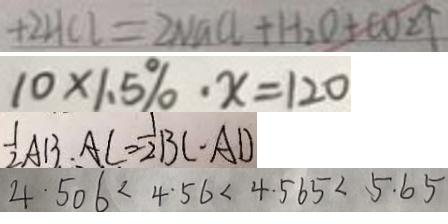<formula> <loc_0><loc_0><loc_500><loc_500>+ 2 H C l = 2 N a C l + H _ { 2 } O + C O _ { 2 } \uparrow 
 1 0 \times 1 . 5 \% \cdot x = 1 2 0 
 \frac { 1 } { 2 } A B \cdot A C = \frac { 1 } { 2 } B C \cdot A D 
 4 . 5 0 6 < 4 . 5 6 < 4 . 5 6 5 < 5 . 6 5</formula> 